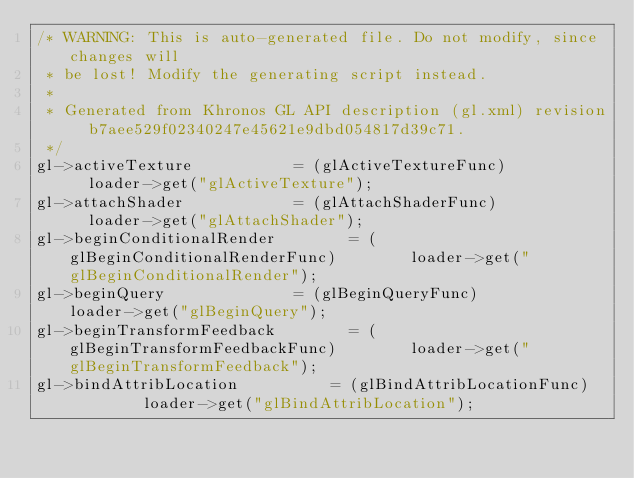<code> <loc_0><loc_0><loc_500><loc_500><_C++_>/* WARNING: This is auto-generated file. Do not modify, since changes will
 * be lost! Modify the generating script instead.
 *
 * Generated from Khronos GL API description (gl.xml) revision b7aee529f02340247e45621e9dbd054817d39c71.
 */
gl->activeTexture						= (glActiveTextureFunc)							loader->get("glActiveTexture");
gl->attachShader						= (glAttachShaderFunc)							loader->get("glAttachShader");
gl->beginConditionalRender				= (glBeginConditionalRenderFunc)				loader->get("glBeginConditionalRender");
gl->beginQuery							= (glBeginQueryFunc)							loader->get("glBeginQuery");
gl->beginTransformFeedback				= (glBeginTransformFeedbackFunc)				loader->get("glBeginTransformFeedback");
gl->bindAttribLocation					= (glBindAttribLocationFunc)					loader->get("glBindAttribLocation");</code> 